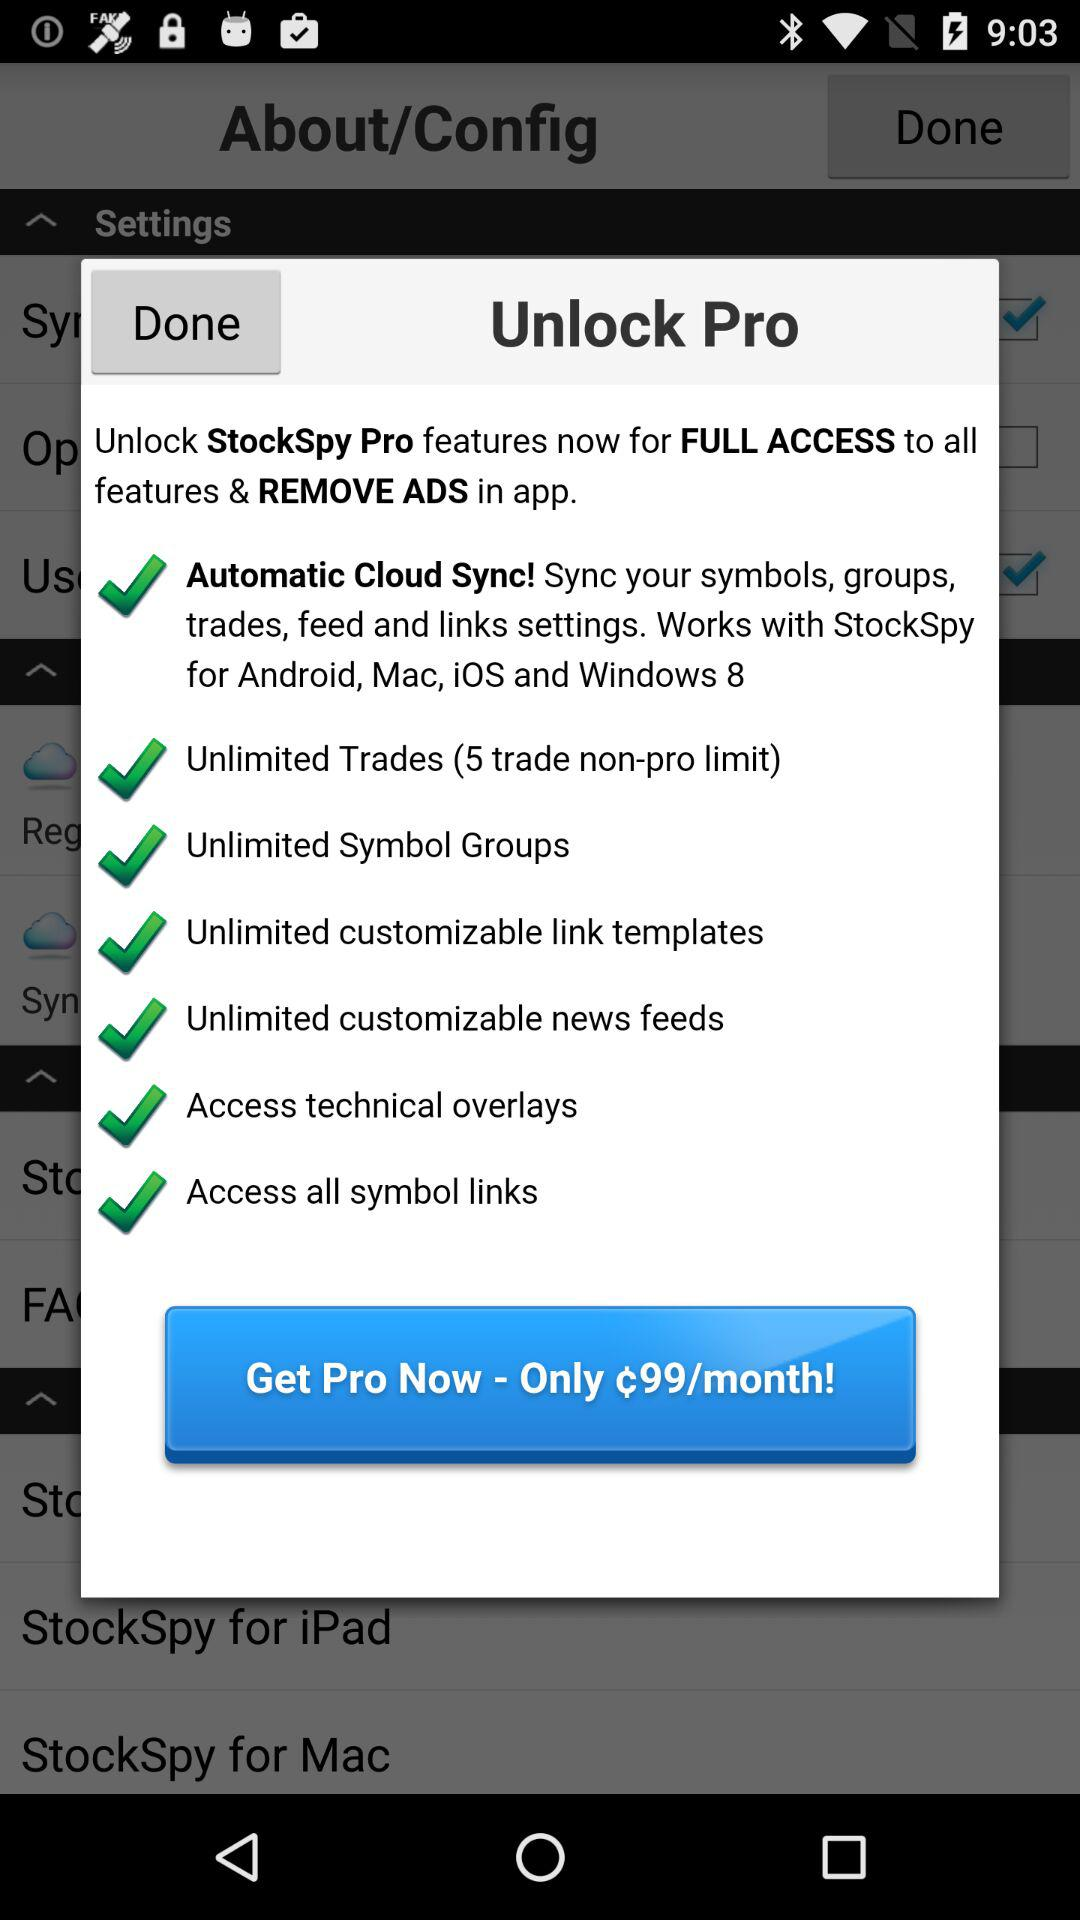What is the per-month price for Pro? The per-month price for Pro is ¢99. 